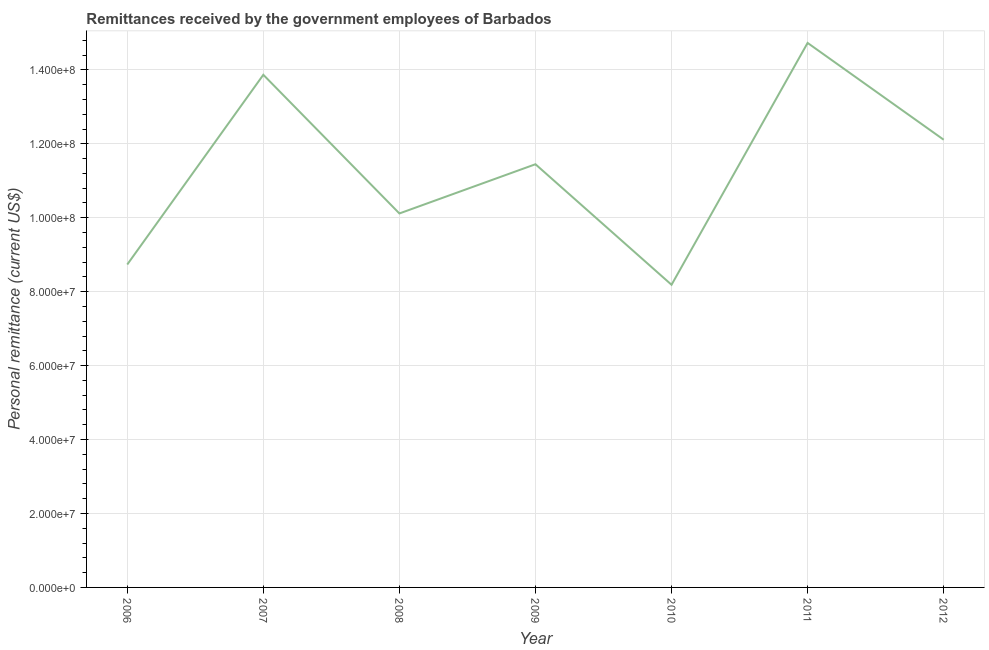What is the personal remittances in 2011?
Your answer should be very brief. 1.47e+08. Across all years, what is the maximum personal remittances?
Your answer should be compact. 1.47e+08. Across all years, what is the minimum personal remittances?
Offer a terse response. 8.19e+07. In which year was the personal remittances minimum?
Provide a short and direct response. 2010. What is the sum of the personal remittances?
Provide a succinct answer. 7.92e+08. What is the difference between the personal remittances in 2011 and 2012?
Your response must be concise. 2.62e+07. What is the average personal remittances per year?
Your answer should be compact. 1.13e+08. What is the median personal remittances?
Offer a terse response. 1.14e+08. In how many years, is the personal remittances greater than 72000000 US$?
Provide a succinct answer. 7. What is the ratio of the personal remittances in 2010 to that in 2011?
Provide a short and direct response. 0.56. What is the difference between the highest and the second highest personal remittances?
Give a very brief answer. 8.62e+06. Is the sum of the personal remittances in 2011 and 2012 greater than the maximum personal remittances across all years?
Your answer should be compact. Yes. What is the difference between the highest and the lowest personal remittances?
Your response must be concise. 6.54e+07. How many lines are there?
Your answer should be compact. 1. What is the difference between two consecutive major ticks on the Y-axis?
Give a very brief answer. 2.00e+07. Are the values on the major ticks of Y-axis written in scientific E-notation?
Provide a short and direct response. Yes. Does the graph contain grids?
Make the answer very short. Yes. What is the title of the graph?
Offer a terse response. Remittances received by the government employees of Barbados. What is the label or title of the Y-axis?
Keep it short and to the point. Personal remittance (current US$). What is the Personal remittance (current US$) of 2006?
Keep it short and to the point. 8.73e+07. What is the Personal remittance (current US$) in 2007?
Ensure brevity in your answer.  1.39e+08. What is the Personal remittance (current US$) of 2008?
Ensure brevity in your answer.  1.01e+08. What is the Personal remittance (current US$) in 2009?
Your answer should be very brief. 1.14e+08. What is the Personal remittance (current US$) in 2010?
Keep it short and to the point. 8.19e+07. What is the Personal remittance (current US$) in 2011?
Give a very brief answer. 1.47e+08. What is the Personal remittance (current US$) of 2012?
Your response must be concise. 1.21e+08. What is the difference between the Personal remittance (current US$) in 2006 and 2007?
Ensure brevity in your answer.  -5.13e+07. What is the difference between the Personal remittance (current US$) in 2006 and 2008?
Provide a short and direct response. -1.38e+07. What is the difference between the Personal remittance (current US$) in 2006 and 2009?
Keep it short and to the point. -2.71e+07. What is the difference between the Personal remittance (current US$) in 2006 and 2010?
Provide a short and direct response. 5.48e+06. What is the difference between the Personal remittance (current US$) in 2006 and 2011?
Your response must be concise. -5.99e+07. What is the difference between the Personal remittance (current US$) in 2006 and 2012?
Give a very brief answer. -3.38e+07. What is the difference between the Personal remittance (current US$) in 2007 and 2008?
Ensure brevity in your answer.  3.75e+07. What is the difference between the Personal remittance (current US$) in 2007 and 2009?
Make the answer very short. 2.42e+07. What is the difference between the Personal remittance (current US$) in 2007 and 2010?
Ensure brevity in your answer.  5.68e+07. What is the difference between the Personal remittance (current US$) in 2007 and 2011?
Provide a short and direct response. -8.62e+06. What is the difference between the Personal remittance (current US$) in 2007 and 2012?
Your answer should be very brief. 1.76e+07. What is the difference between the Personal remittance (current US$) in 2008 and 2009?
Offer a terse response. -1.33e+07. What is the difference between the Personal remittance (current US$) in 2008 and 2010?
Give a very brief answer. 1.93e+07. What is the difference between the Personal remittance (current US$) in 2008 and 2011?
Provide a short and direct response. -4.61e+07. What is the difference between the Personal remittance (current US$) in 2008 and 2012?
Make the answer very short. -1.99e+07. What is the difference between the Personal remittance (current US$) in 2009 and 2010?
Ensure brevity in your answer.  3.26e+07. What is the difference between the Personal remittance (current US$) in 2009 and 2011?
Your answer should be compact. -3.28e+07. What is the difference between the Personal remittance (current US$) in 2009 and 2012?
Provide a succinct answer. -6.63e+06. What is the difference between the Personal remittance (current US$) in 2010 and 2011?
Give a very brief answer. -6.54e+07. What is the difference between the Personal remittance (current US$) in 2010 and 2012?
Ensure brevity in your answer.  -3.92e+07. What is the difference between the Personal remittance (current US$) in 2011 and 2012?
Make the answer very short. 2.62e+07. What is the ratio of the Personal remittance (current US$) in 2006 to that in 2007?
Keep it short and to the point. 0.63. What is the ratio of the Personal remittance (current US$) in 2006 to that in 2008?
Make the answer very short. 0.86. What is the ratio of the Personal remittance (current US$) in 2006 to that in 2009?
Keep it short and to the point. 0.76. What is the ratio of the Personal remittance (current US$) in 2006 to that in 2010?
Your response must be concise. 1.07. What is the ratio of the Personal remittance (current US$) in 2006 to that in 2011?
Offer a very short reply. 0.59. What is the ratio of the Personal remittance (current US$) in 2006 to that in 2012?
Make the answer very short. 0.72. What is the ratio of the Personal remittance (current US$) in 2007 to that in 2008?
Your answer should be very brief. 1.37. What is the ratio of the Personal remittance (current US$) in 2007 to that in 2009?
Your answer should be compact. 1.21. What is the ratio of the Personal remittance (current US$) in 2007 to that in 2010?
Keep it short and to the point. 1.69. What is the ratio of the Personal remittance (current US$) in 2007 to that in 2011?
Your answer should be very brief. 0.94. What is the ratio of the Personal remittance (current US$) in 2007 to that in 2012?
Your answer should be compact. 1.15. What is the ratio of the Personal remittance (current US$) in 2008 to that in 2009?
Offer a terse response. 0.88. What is the ratio of the Personal remittance (current US$) in 2008 to that in 2010?
Your answer should be very brief. 1.24. What is the ratio of the Personal remittance (current US$) in 2008 to that in 2011?
Provide a succinct answer. 0.69. What is the ratio of the Personal remittance (current US$) in 2008 to that in 2012?
Ensure brevity in your answer.  0.83. What is the ratio of the Personal remittance (current US$) in 2009 to that in 2010?
Provide a succinct answer. 1.4. What is the ratio of the Personal remittance (current US$) in 2009 to that in 2011?
Keep it short and to the point. 0.78. What is the ratio of the Personal remittance (current US$) in 2009 to that in 2012?
Offer a very short reply. 0.94. What is the ratio of the Personal remittance (current US$) in 2010 to that in 2011?
Keep it short and to the point. 0.56. What is the ratio of the Personal remittance (current US$) in 2010 to that in 2012?
Your answer should be very brief. 0.68. What is the ratio of the Personal remittance (current US$) in 2011 to that in 2012?
Make the answer very short. 1.22. 